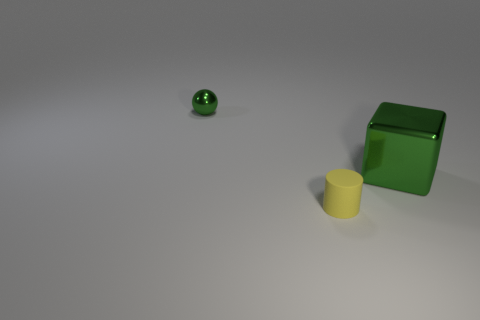Add 3 yellow cylinders. How many objects exist? 6 Subtract all balls. How many objects are left? 2 Add 3 rubber objects. How many rubber objects exist? 4 Subtract 0 gray spheres. How many objects are left? 3 Subtract all big metal cubes. Subtract all small rubber cylinders. How many objects are left? 1 Add 1 yellow things. How many yellow things are left? 2 